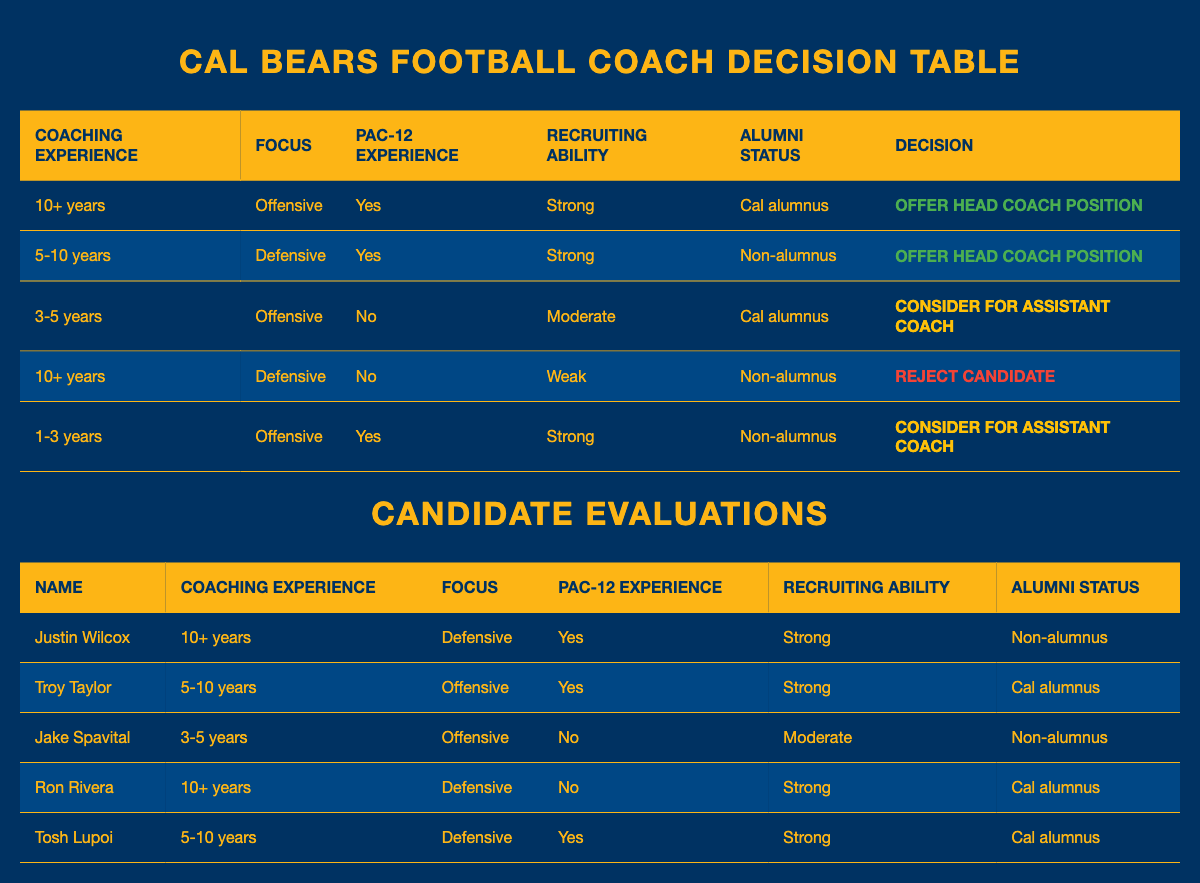What decision is made for a candidate with 10+ years of coaching experience, defensive focus, Pac-12 experience, strong recruiting ability, and who is a non-alumnus? The candidate's attributes match the fourth rule in the table, which specifies that if they have 10+ years of coaching experience, a defensive focus, no Pac-12 experience, weak recruiting ability, and are a non-alumnus, the decision would be to reject the candidate. However, in this specific case, the given attributes don't invoke any existing rule specifically outlining non-alumnus. The only candidate with 10+ years and defensive focus is Justin Wilcox, who has Pac-12 experience. Hence, by checking the table, their decision is to offer the head coach position.
Answer: Offer head coach position How many candidates are considered for the assistant coach position? The rules indicate that a candidate is considered for the assistant coach position if they fall into specific criteria outlined in the third and fifth rules. Analyzing the table, the first candidate meeting those conditions is Jake Spavital, and the second is the one in the last rule regarding an offender with strong recruiting ability and non-alumnus status. Thus, there are two candidates to consider.
Answer: 2 Is Troy Taylor a Cal alumnus? The table shows that Troy Taylor's alumni status is marked as "Cal alumnus," meaning he did graduate from the University of California Berkeley.
Answer: Yes Which candidates have strong recruiting ability and are Cal alumni? To find the candidates who possess both strong recruiting ability and are Cal alumni, we check the table and filter for candidates meeting these criteria. Troy Taylor and Tosh Lupoi meet this condition as they are both Cal alumni with strong recruiting records.
Answer: Troy Taylor, Tosh Lupoi What is the average coaching experience of the candidates who have been offered the head coach position? The candidates who were offered the head coach position are Justin Wilcox (10+ years) and Troy Taylor (5-10 years). To calculate the average, we categorize them: "10+" years corresponds to 10 years, while "5-10" can be averaged as (5+10)/2 = 7.5. Their average coaching experience thus is (10 + 7.5) / 2 = 8.75 years.
Answer: 8.75 years 